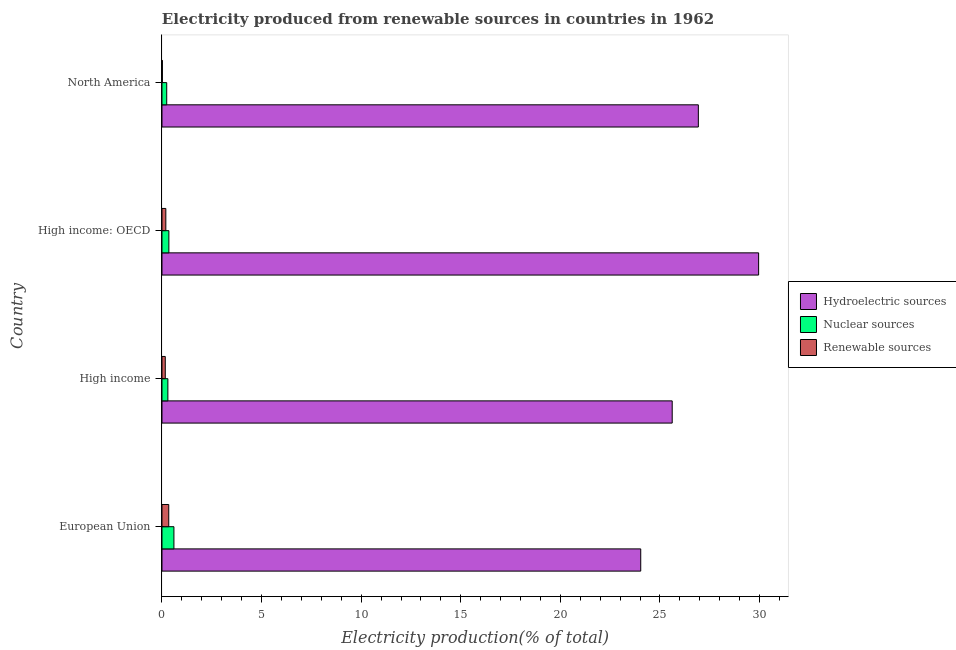How many groups of bars are there?
Keep it short and to the point. 4. Are the number of bars per tick equal to the number of legend labels?
Provide a short and direct response. Yes. How many bars are there on the 3rd tick from the top?
Offer a terse response. 3. How many bars are there on the 3rd tick from the bottom?
Offer a very short reply. 3. What is the label of the 2nd group of bars from the top?
Offer a terse response. High income: OECD. In how many cases, is the number of bars for a given country not equal to the number of legend labels?
Offer a terse response. 0. What is the percentage of electricity produced by renewable sources in North America?
Offer a very short reply. 0.02. Across all countries, what is the maximum percentage of electricity produced by renewable sources?
Give a very brief answer. 0.34. Across all countries, what is the minimum percentage of electricity produced by renewable sources?
Keep it short and to the point. 0.02. In which country was the percentage of electricity produced by hydroelectric sources minimum?
Offer a very short reply. European Union. What is the total percentage of electricity produced by hydroelectric sources in the graph?
Provide a succinct answer. 106.52. What is the difference between the percentage of electricity produced by hydroelectric sources in European Union and that in High income?
Give a very brief answer. -1.58. What is the difference between the percentage of electricity produced by hydroelectric sources in High income: OECD and the percentage of electricity produced by nuclear sources in European Union?
Your answer should be very brief. 29.35. What is the average percentage of electricity produced by nuclear sources per country?
Ensure brevity in your answer.  0.37. What is the difference between the percentage of electricity produced by hydroelectric sources and percentage of electricity produced by nuclear sources in North America?
Keep it short and to the point. 26.69. In how many countries, is the percentage of electricity produced by nuclear sources greater than 15 %?
Offer a very short reply. 0. What is the ratio of the percentage of electricity produced by nuclear sources in European Union to that in High income: OECD?
Offer a very short reply. 1.73. Is the percentage of electricity produced by nuclear sources in European Union less than that in High income?
Keep it short and to the point. No. What is the difference between the highest and the second highest percentage of electricity produced by renewable sources?
Your answer should be compact. 0.15. What is the difference between the highest and the lowest percentage of electricity produced by renewable sources?
Keep it short and to the point. 0.32. Is the sum of the percentage of electricity produced by hydroelectric sources in European Union and North America greater than the maximum percentage of electricity produced by nuclear sources across all countries?
Give a very brief answer. Yes. What does the 1st bar from the top in North America represents?
Make the answer very short. Renewable sources. What does the 3rd bar from the bottom in High income: OECD represents?
Your response must be concise. Renewable sources. Is it the case that in every country, the sum of the percentage of electricity produced by hydroelectric sources and percentage of electricity produced by nuclear sources is greater than the percentage of electricity produced by renewable sources?
Your answer should be very brief. Yes. How many bars are there?
Offer a terse response. 12. How many countries are there in the graph?
Offer a terse response. 4. What is the difference between two consecutive major ticks on the X-axis?
Make the answer very short. 5. How many legend labels are there?
Offer a very short reply. 3. How are the legend labels stacked?
Make the answer very short. Vertical. What is the title of the graph?
Ensure brevity in your answer.  Electricity produced from renewable sources in countries in 1962. Does "Domestic economy" appear as one of the legend labels in the graph?
Your answer should be very brief. No. What is the label or title of the Y-axis?
Offer a very short reply. Country. What is the Electricity production(% of total) of Hydroelectric sources in European Union?
Ensure brevity in your answer.  24.03. What is the Electricity production(% of total) in Nuclear sources in European Union?
Provide a succinct answer. 0.6. What is the Electricity production(% of total) in Renewable sources in European Union?
Make the answer very short. 0.34. What is the Electricity production(% of total) in Hydroelectric sources in High income?
Your response must be concise. 25.61. What is the Electricity production(% of total) of Nuclear sources in High income?
Keep it short and to the point. 0.3. What is the Electricity production(% of total) of Renewable sources in High income?
Your response must be concise. 0.17. What is the Electricity production(% of total) in Hydroelectric sources in High income: OECD?
Make the answer very short. 29.95. What is the Electricity production(% of total) in Nuclear sources in High income: OECD?
Offer a terse response. 0.35. What is the Electricity production(% of total) of Renewable sources in High income: OECD?
Make the answer very short. 0.19. What is the Electricity production(% of total) in Hydroelectric sources in North America?
Your answer should be very brief. 26.93. What is the Electricity production(% of total) in Nuclear sources in North America?
Your answer should be very brief. 0.24. What is the Electricity production(% of total) of Renewable sources in North America?
Your answer should be compact. 0.02. Across all countries, what is the maximum Electricity production(% of total) of Hydroelectric sources?
Your answer should be very brief. 29.95. Across all countries, what is the maximum Electricity production(% of total) of Nuclear sources?
Provide a succinct answer. 0.6. Across all countries, what is the maximum Electricity production(% of total) in Renewable sources?
Offer a terse response. 0.34. Across all countries, what is the minimum Electricity production(% of total) in Hydroelectric sources?
Offer a very short reply. 24.03. Across all countries, what is the minimum Electricity production(% of total) of Nuclear sources?
Ensure brevity in your answer.  0.24. Across all countries, what is the minimum Electricity production(% of total) in Renewable sources?
Ensure brevity in your answer.  0.02. What is the total Electricity production(% of total) of Hydroelectric sources in the graph?
Make the answer very short. 106.52. What is the total Electricity production(% of total) of Nuclear sources in the graph?
Your answer should be compact. 1.48. What is the total Electricity production(% of total) in Renewable sources in the graph?
Offer a terse response. 0.72. What is the difference between the Electricity production(% of total) in Hydroelectric sources in European Union and that in High income?
Provide a short and direct response. -1.58. What is the difference between the Electricity production(% of total) in Nuclear sources in European Union and that in High income?
Your answer should be very brief. 0.3. What is the difference between the Electricity production(% of total) of Renewable sources in European Union and that in High income?
Provide a succinct answer. 0.17. What is the difference between the Electricity production(% of total) of Hydroelectric sources in European Union and that in High income: OECD?
Give a very brief answer. -5.92. What is the difference between the Electricity production(% of total) of Nuclear sources in European Union and that in High income: OECD?
Make the answer very short. 0.25. What is the difference between the Electricity production(% of total) in Renewable sources in European Union and that in High income: OECD?
Your answer should be compact. 0.15. What is the difference between the Electricity production(% of total) in Hydroelectric sources in European Union and that in North America?
Your answer should be very brief. -2.89. What is the difference between the Electricity production(% of total) in Nuclear sources in European Union and that in North America?
Ensure brevity in your answer.  0.36. What is the difference between the Electricity production(% of total) of Renewable sources in European Union and that in North America?
Your answer should be compact. 0.32. What is the difference between the Electricity production(% of total) of Hydroelectric sources in High income and that in High income: OECD?
Provide a short and direct response. -4.34. What is the difference between the Electricity production(% of total) of Nuclear sources in High income and that in High income: OECD?
Offer a very short reply. -0.05. What is the difference between the Electricity production(% of total) of Renewable sources in High income and that in High income: OECD?
Your response must be concise. -0.03. What is the difference between the Electricity production(% of total) in Hydroelectric sources in High income and that in North America?
Your answer should be very brief. -1.31. What is the difference between the Electricity production(% of total) of Nuclear sources in High income and that in North America?
Your answer should be very brief. 0.06. What is the difference between the Electricity production(% of total) in Renewable sources in High income and that in North America?
Your answer should be compact. 0.14. What is the difference between the Electricity production(% of total) in Hydroelectric sources in High income: OECD and that in North America?
Keep it short and to the point. 3.03. What is the difference between the Electricity production(% of total) of Nuclear sources in High income: OECD and that in North America?
Offer a very short reply. 0.11. What is the difference between the Electricity production(% of total) in Renewable sources in High income: OECD and that in North America?
Offer a very short reply. 0.17. What is the difference between the Electricity production(% of total) of Hydroelectric sources in European Union and the Electricity production(% of total) of Nuclear sources in High income?
Your response must be concise. 23.74. What is the difference between the Electricity production(% of total) of Hydroelectric sources in European Union and the Electricity production(% of total) of Renewable sources in High income?
Offer a very short reply. 23.87. What is the difference between the Electricity production(% of total) of Nuclear sources in European Union and the Electricity production(% of total) of Renewable sources in High income?
Make the answer very short. 0.43. What is the difference between the Electricity production(% of total) in Hydroelectric sources in European Union and the Electricity production(% of total) in Nuclear sources in High income: OECD?
Your response must be concise. 23.69. What is the difference between the Electricity production(% of total) of Hydroelectric sources in European Union and the Electricity production(% of total) of Renewable sources in High income: OECD?
Give a very brief answer. 23.84. What is the difference between the Electricity production(% of total) of Nuclear sources in European Union and the Electricity production(% of total) of Renewable sources in High income: OECD?
Your answer should be very brief. 0.41. What is the difference between the Electricity production(% of total) of Hydroelectric sources in European Union and the Electricity production(% of total) of Nuclear sources in North America?
Offer a terse response. 23.8. What is the difference between the Electricity production(% of total) in Hydroelectric sources in European Union and the Electricity production(% of total) in Renewable sources in North America?
Give a very brief answer. 24.01. What is the difference between the Electricity production(% of total) of Nuclear sources in European Union and the Electricity production(% of total) of Renewable sources in North America?
Your response must be concise. 0.58. What is the difference between the Electricity production(% of total) of Hydroelectric sources in High income and the Electricity production(% of total) of Nuclear sources in High income: OECD?
Keep it short and to the point. 25.27. What is the difference between the Electricity production(% of total) of Hydroelectric sources in High income and the Electricity production(% of total) of Renewable sources in High income: OECD?
Your response must be concise. 25.42. What is the difference between the Electricity production(% of total) of Nuclear sources in High income and the Electricity production(% of total) of Renewable sources in High income: OECD?
Your answer should be very brief. 0.1. What is the difference between the Electricity production(% of total) of Hydroelectric sources in High income and the Electricity production(% of total) of Nuclear sources in North America?
Make the answer very short. 25.38. What is the difference between the Electricity production(% of total) of Hydroelectric sources in High income and the Electricity production(% of total) of Renewable sources in North America?
Your answer should be compact. 25.59. What is the difference between the Electricity production(% of total) of Nuclear sources in High income and the Electricity production(% of total) of Renewable sources in North America?
Keep it short and to the point. 0.28. What is the difference between the Electricity production(% of total) in Hydroelectric sources in High income: OECD and the Electricity production(% of total) in Nuclear sources in North America?
Make the answer very short. 29.71. What is the difference between the Electricity production(% of total) in Hydroelectric sources in High income: OECD and the Electricity production(% of total) in Renewable sources in North America?
Provide a short and direct response. 29.93. What is the difference between the Electricity production(% of total) of Nuclear sources in High income: OECD and the Electricity production(% of total) of Renewable sources in North America?
Make the answer very short. 0.33. What is the average Electricity production(% of total) in Hydroelectric sources per country?
Provide a short and direct response. 26.63. What is the average Electricity production(% of total) of Nuclear sources per country?
Provide a succinct answer. 0.37. What is the average Electricity production(% of total) of Renewable sources per country?
Your answer should be compact. 0.18. What is the difference between the Electricity production(% of total) of Hydroelectric sources and Electricity production(% of total) of Nuclear sources in European Union?
Provide a short and direct response. 23.43. What is the difference between the Electricity production(% of total) of Hydroelectric sources and Electricity production(% of total) of Renewable sources in European Union?
Offer a terse response. 23.69. What is the difference between the Electricity production(% of total) in Nuclear sources and Electricity production(% of total) in Renewable sources in European Union?
Your answer should be very brief. 0.26. What is the difference between the Electricity production(% of total) of Hydroelectric sources and Electricity production(% of total) of Nuclear sources in High income?
Your answer should be compact. 25.32. What is the difference between the Electricity production(% of total) in Hydroelectric sources and Electricity production(% of total) in Renewable sources in High income?
Provide a short and direct response. 25.45. What is the difference between the Electricity production(% of total) in Nuclear sources and Electricity production(% of total) in Renewable sources in High income?
Offer a terse response. 0.13. What is the difference between the Electricity production(% of total) of Hydroelectric sources and Electricity production(% of total) of Nuclear sources in High income: OECD?
Your answer should be compact. 29.61. What is the difference between the Electricity production(% of total) in Hydroelectric sources and Electricity production(% of total) in Renewable sources in High income: OECD?
Give a very brief answer. 29.76. What is the difference between the Electricity production(% of total) of Nuclear sources and Electricity production(% of total) of Renewable sources in High income: OECD?
Keep it short and to the point. 0.15. What is the difference between the Electricity production(% of total) of Hydroelectric sources and Electricity production(% of total) of Nuclear sources in North America?
Provide a short and direct response. 26.69. What is the difference between the Electricity production(% of total) in Hydroelectric sources and Electricity production(% of total) in Renewable sources in North America?
Make the answer very short. 26.91. What is the difference between the Electricity production(% of total) of Nuclear sources and Electricity production(% of total) of Renewable sources in North America?
Provide a short and direct response. 0.22. What is the ratio of the Electricity production(% of total) in Hydroelectric sources in European Union to that in High income?
Give a very brief answer. 0.94. What is the ratio of the Electricity production(% of total) in Nuclear sources in European Union to that in High income?
Give a very brief answer. 2.02. What is the ratio of the Electricity production(% of total) of Renewable sources in European Union to that in High income?
Provide a succinct answer. 2.06. What is the ratio of the Electricity production(% of total) of Hydroelectric sources in European Union to that in High income: OECD?
Ensure brevity in your answer.  0.8. What is the ratio of the Electricity production(% of total) of Nuclear sources in European Union to that in High income: OECD?
Give a very brief answer. 1.73. What is the ratio of the Electricity production(% of total) in Renewable sources in European Union to that in High income: OECD?
Your answer should be very brief. 1.76. What is the ratio of the Electricity production(% of total) in Hydroelectric sources in European Union to that in North America?
Provide a succinct answer. 0.89. What is the ratio of the Electricity production(% of total) of Nuclear sources in European Union to that in North America?
Provide a short and direct response. 2.52. What is the ratio of the Electricity production(% of total) of Renewable sources in European Union to that in North America?
Offer a very short reply. 16.89. What is the ratio of the Electricity production(% of total) in Hydroelectric sources in High income to that in High income: OECD?
Give a very brief answer. 0.86. What is the ratio of the Electricity production(% of total) of Nuclear sources in High income to that in High income: OECD?
Give a very brief answer. 0.86. What is the ratio of the Electricity production(% of total) of Renewable sources in High income to that in High income: OECD?
Give a very brief answer. 0.86. What is the ratio of the Electricity production(% of total) in Hydroelectric sources in High income to that in North America?
Make the answer very short. 0.95. What is the ratio of the Electricity production(% of total) of Nuclear sources in High income to that in North America?
Offer a very short reply. 1.25. What is the ratio of the Electricity production(% of total) of Renewable sources in High income to that in North America?
Provide a succinct answer. 8.21. What is the ratio of the Electricity production(% of total) of Hydroelectric sources in High income: OECD to that in North America?
Provide a succinct answer. 1.11. What is the ratio of the Electricity production(% of total) of Nuclear sources in High income: OECD to that in North America?
Ensure brevity in your answer.  1.46. What is the ratio of the Electricity production(% of total) of Renewable sources in High income: OECD to that in North America?
Give a very brief answer. 9.6. What is the difference between the highest and the second highest Electricity production(% of total) in Hydroelectric sources?
Provide a short and direct response. 3.03. What is the difference between the highest and the second highest Electricity production(% of total) in Nuclear sources?
Provide a short and direct response. 0.25. What is the difference between the highest and the second highest Electricity production(% of total) in Renewable sources?
Your response must be concise. 0.15. What is the difference between the highest and the lowest Electricity production(% of total) in Hydroelectric sources?
Give a very brief answer. 5.92. What is the difference between the highest and the lowest Electricity production(% of total) of Nuclear sources?
Your response must be concise. 0.36. What is the difference between the highest and the lowest Electricity production(% of total) of Renewable sources?
Offer a very short reply. 0.32. 